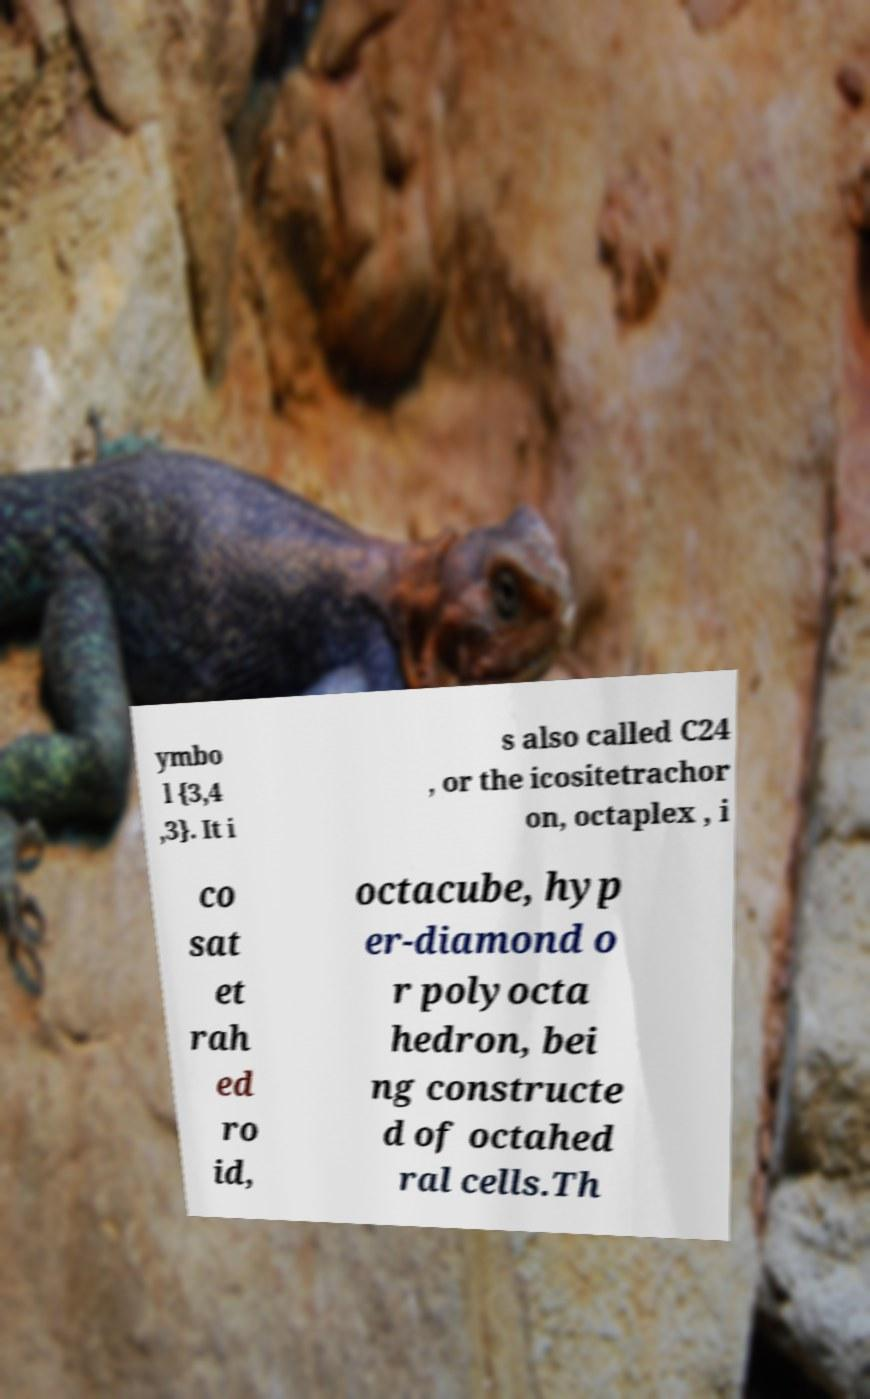Can you read and provide the text displayed in the image?This photo seems to have some interesting text. Can you extract and type it out for me? ymbo l {3,4 ,3}. It i s also called C24 , or the icositetrachor on, octaplex , i co sat et rah ed ro id, octacube, hyp er-diamond o r polyocta hedron, bei ng constructe d of octahed ral cells.Th 